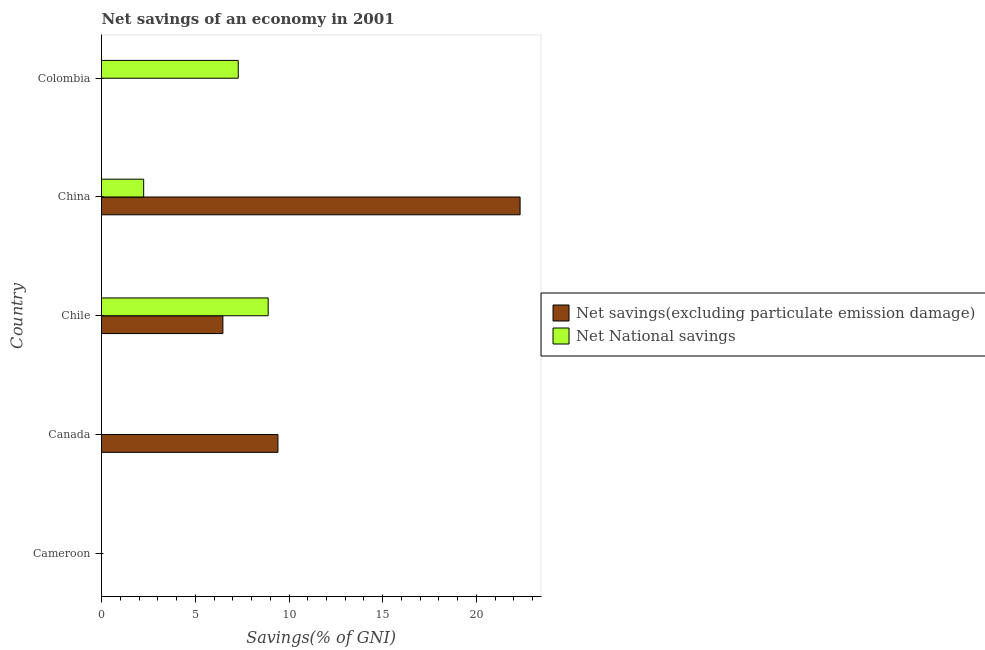Are the number of bars per tick equal to the number of legend labels?
Keep it short and to the point. No. How many bars are there on the 1st tick from the top?
Provide a succinct answer. 1. How many bars are there on the 4th tick from the bottom?
Keep it short and to the point. 2. What is the label of the 5th group of bars from the top?
Offer a terse response. Cameroon. In how many cases, is the number of bars for a given country not equal to the number of legend labels?
Make the answer very short. 3. What is the net national savings in Chile?
Your response must be concise. 8.89. Across all countries, what is the maximum net national savings?
Keep it short and to the point. 8.89. Across all countries, what is the minimum net savings(excluding particulate emission damage)?
Give a very brief answer. 0. What is the total net national savings in the graph?
Your answer should be very brief. 18.43. What is the difference between the net savings(excluding particulate emission damage) in Canada and that in China?
Offer a terse response. -12.92. What is the difference between the net savings(excluding particulate emission damage) in China and the net national savings in Chile?
Give a very brief answer. 13.44. What is the average net savings(excluding particulate emission damage) per country?
Your answer should be very brief. 7.64. What is the difference between the net savings(excluding particulate emission damage) and net national savings in China?
Provide a succinct answer. 20.08. What is the ratio of the net national savings in Chile to that in China?
Your response must be concise. 3.95. Is the difference between the net savings(excluding particulate emission damage) in Chile and China greater than the difference between the net national savings in Chile and China?
Your answer should be compact. No. What is the difference between the highest and the second highest net savings(excluding particulate emission damage)?
Provide a succinct answer. 12.92. What is the difference between the highest and the lowest net national savings?
Provide a succinct answer. 8.89. Are all the bars in the graph horizontal?
Offer a very short reply. Yes. Are the values on the major ticks of X-axis written in scientific E-notation?
Provide a succinct answer. No. Does the graph contain grids?
Keep it short and to the point. No. How many legend labels are there?
Your response must be concise. 2. How are the legend labels stacked?
Ensure brevity in your answer.  Vertical. What is the title of the graph?
Your answer should be very brief. Net savings of an economy in 2001. What is the label or title of the X-axis?
Keep it short and to the point. Savings(% of GNI). What is the Savings(% of GNI) of Net National savings in Cameroon?
Your answer should be compact. 0. What is the Savings(% of GNI) of Net savings(excluding particulate emission damage) in Canada?
Provide a short and direct response. 9.41. What is the Savings(% of GNI) in Net savings(excluding particulate emission damage) in Chile?
Ensure brevity in your answer.  6.47. What is the Savings(% of GNI) of Net National savings in Chile?
Make the answer very short. 8.89. What is the Savings(% of GNI) of Net savings(excluding particulate emission damage) in China?
Make the answer very short. 22.33. What is the Savings(% of GNI) of Net National savings in China?
Keep it short and to the point. 2.25. What is the Savings(% of GNI) in Net National savings in Colombia?
Keep it short and to the point. 7.29. Across all countries, what is the maximum Savings(% of GNI) of Net savings(excluding particulate emission damage)?
Your answer should be compact. 22.33. Across all countries, what is the maximum Savings(% of GNI) of Net National savings?
Give a very brief answer. 8.89. Across all countries, what is the minimum Savings(% of GNI) of Net savings(excluding particulate emission damage)?
Provide a succinct answer. 0. What is the total Savings(% of GNI) in Net savings(excluding particulate emission damage) in the graph?
Your response must be concise. 38.21. What is the total Savings(% of GNI) in Net National savings in the graph?
Offer a very short reply. 18.43. What is the difference between the Savings(% of GNI) in Net savings(excluding particulate emission damage) in Canada and that in Chile?
Provide a short and direct response. 2.94. What is the difference between the Savings(% of GNI) in Net savings(excluding particulate emission damage) in Canada and that in China?
Make the answer very short. -12.92. What is the difference between the Savings(% of GNI) in Net savings(excluding particulate emission damage) in Chile and that in China?
Your answer should be compact. -15.85. What is the difference between the Savings(% of GNI) in Net National savings in Chile and that in China?
Keep it short and to the point. 6.64. What is the difference between the Savings(% of GNI) of Net National savings in Chile and that in Colombia?
Your response must be concise. 1.6. What is the difference between the Savings(% of GNI) of Net National savings in China and that in Colombia?
Provide a succinct answer. -5.04. What is the difference between the Savings(% of GNI) of Net savings(excluding particulate emission damage) in Canada and the Savings(% of GNI) of Net National savings in Chile?
Make the answer very short. 0.52. What is the difference between the Savings(% of GNI) of Net savings(excluding particulate emission damage) in Canada and the Savings(% of GNI) of Net National savings in China?
Offer a terse response. 7.16. What is the difference between the Savings(% of GNI) of Net savings(excluding particulate emission damage) in Canada and the Savings(% of GNI) of Net National savings in Colombia?
Keep it short and to the point. 2.12. What is the difference between the Savings(% of GNI) in Net savings(excluding particulate emission damage) in Chile and the Savings(% of GNI) in Net National savings in China?
Your answer should be very brief. 4.22. What is the difference between the Savings(% of GNI) of Net savings(excluding particulate emission damage) in Chile and the Savings(% of GNI) of Net National savings in Colombia?
Your answer should be very brief. -0.82. What is the difference between the Savings(% of GNI) in Net savings(excluding particulate emission damage) in China and the Savings(% of GNI) in Net National savings in Colombia?
Provide a short and direct response. 15.03. What is the average Savings(% of GNI) of Net savings(excluding particulate emission damage) per country?
Your answer should be very brief. 7.64. What is the average Savings(% of GNI) of Net National savings per country?
Ensure brevity in your answer.  3.69. What is the difference between the Savings(% of GNI) of Net savings(excluding particulate emission damage) and Savings(% of GNI) of Net National savings in Chile?
Your response must be concise. -2.42. What is the difference between the Savings(% of GNI) of Net savings(excluding particulate emission damage) and Savings(% of GNI) of Net National savings in China?
Your response must be concise. 20.08. What is the ratio of the Savings(% of GNI) in Net savings(excluding particulate emission damage) in Canada to that in Chile?
Provide a short and direct response. 1.45. What is the ratio of the Savings(% of GNI) of Net savings(excluding particulate emission damage) in Canada to that in China?
Offer a very short reply. 0.42. What is the ratio of the Savings(% of GNI) in Net savings(excluding particulate emission damage) in Chile to that in China?
Make the answer very short. 0.29. What is the ratio of the Savings(% of GNI) of Net National savings in Chile to that in China?
Ensure brevity in your answer.  3.95. What is the ratio of the Savings(% of GNI) of Net National savings in Chile to that in Colombia?
Ensure brevity in your answer.  1.22. What is the ratio of the Savings(% of GNI) in Net National savings in China to that in Colombia?
Ensure brevity in your answer.  0.31. What is the difference between the highest and the second highest Savings(% of GNI) in Net savings(excluding particulate emission damage)?
Make the answer very short. 12.92. What is the difference between the highest and the second highest Savings(% of GNI) of Net National savings?
Provide a succinct answer. 1.6. What is the difference between the highest and the lowest Savings(% of GNI) in Net savings(excluding particulate emission damage)?
Offer a terse response. 22.33. What is the difference between the highest and the lowest Savings(% of GNI) of Net National savings?
Give a very brief answer. 8.89. 